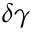<formula> <loc_0><loc_0><loc_500><loc_500>\delta \gamma</formula> 